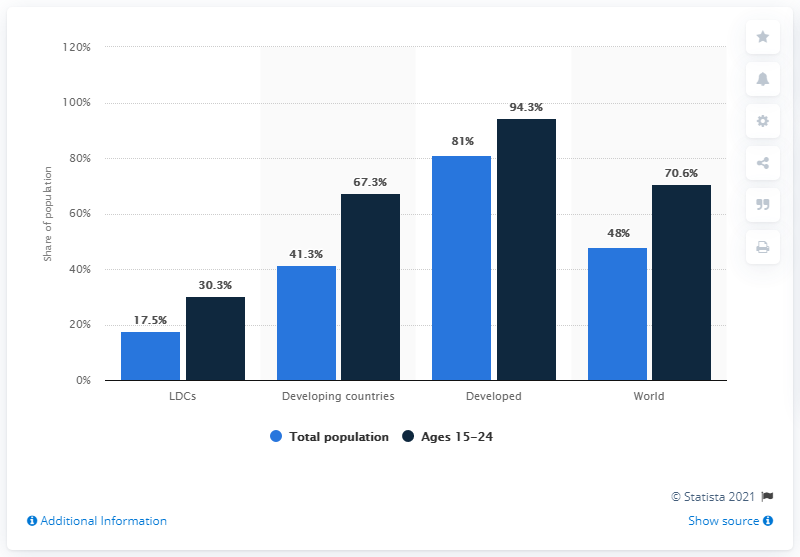Outline some significant characteristics in this image. The age segment and type of county with the highest utilization is [Developed, Ages 15-24]. The total number of "total population" segments is 187.8. 